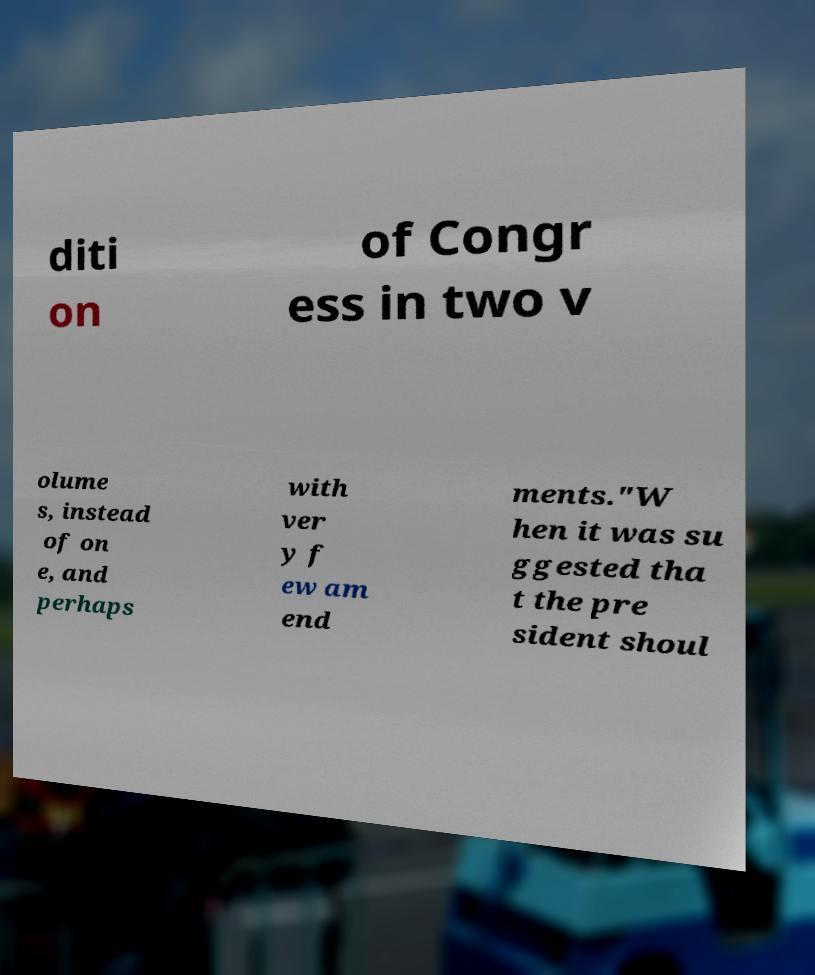Please identify and transcribe the text found in this image. diti on of Congr ess in two v olume s, instead of on e, and perhaps with ver y f ew am end ments."W hen it was su ggested tha t the pre sident shoul 